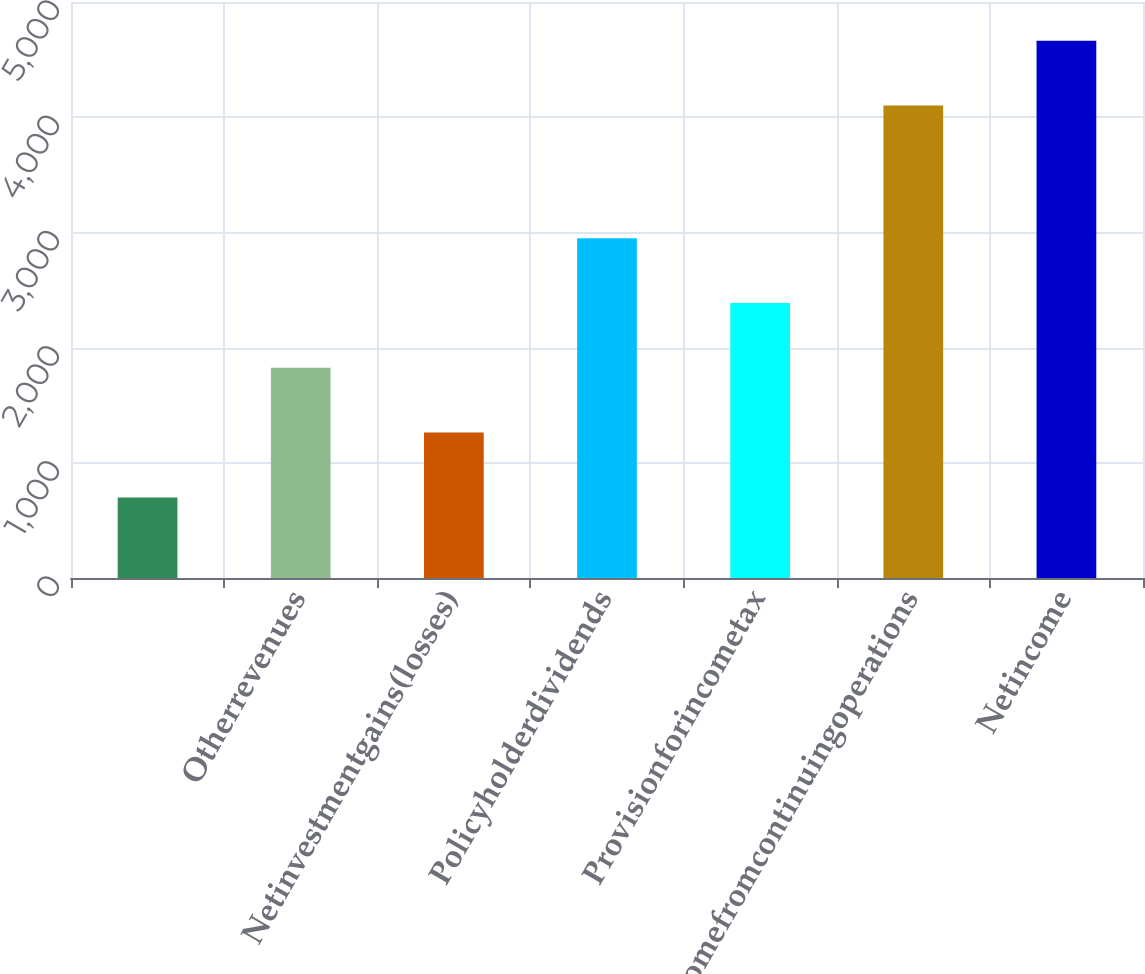Convert chart. <chart><loc_0><loc_0><loc_500><loc_500><bar_chart><ecel><fcel>Otherrevenues<fcel>Netinvestmentgains(losses)<fcel>Policyholderdividends<fcel>Provisionforincometax<fcel>Incomefromcontinuingoperations<fcel>Netincome<nl><fcel>699.5<fcel>1824.5<fcel>1262<fcel>2949.5<fcel>2387<fcel>4102<fcel>4664.5<nl></chart> 